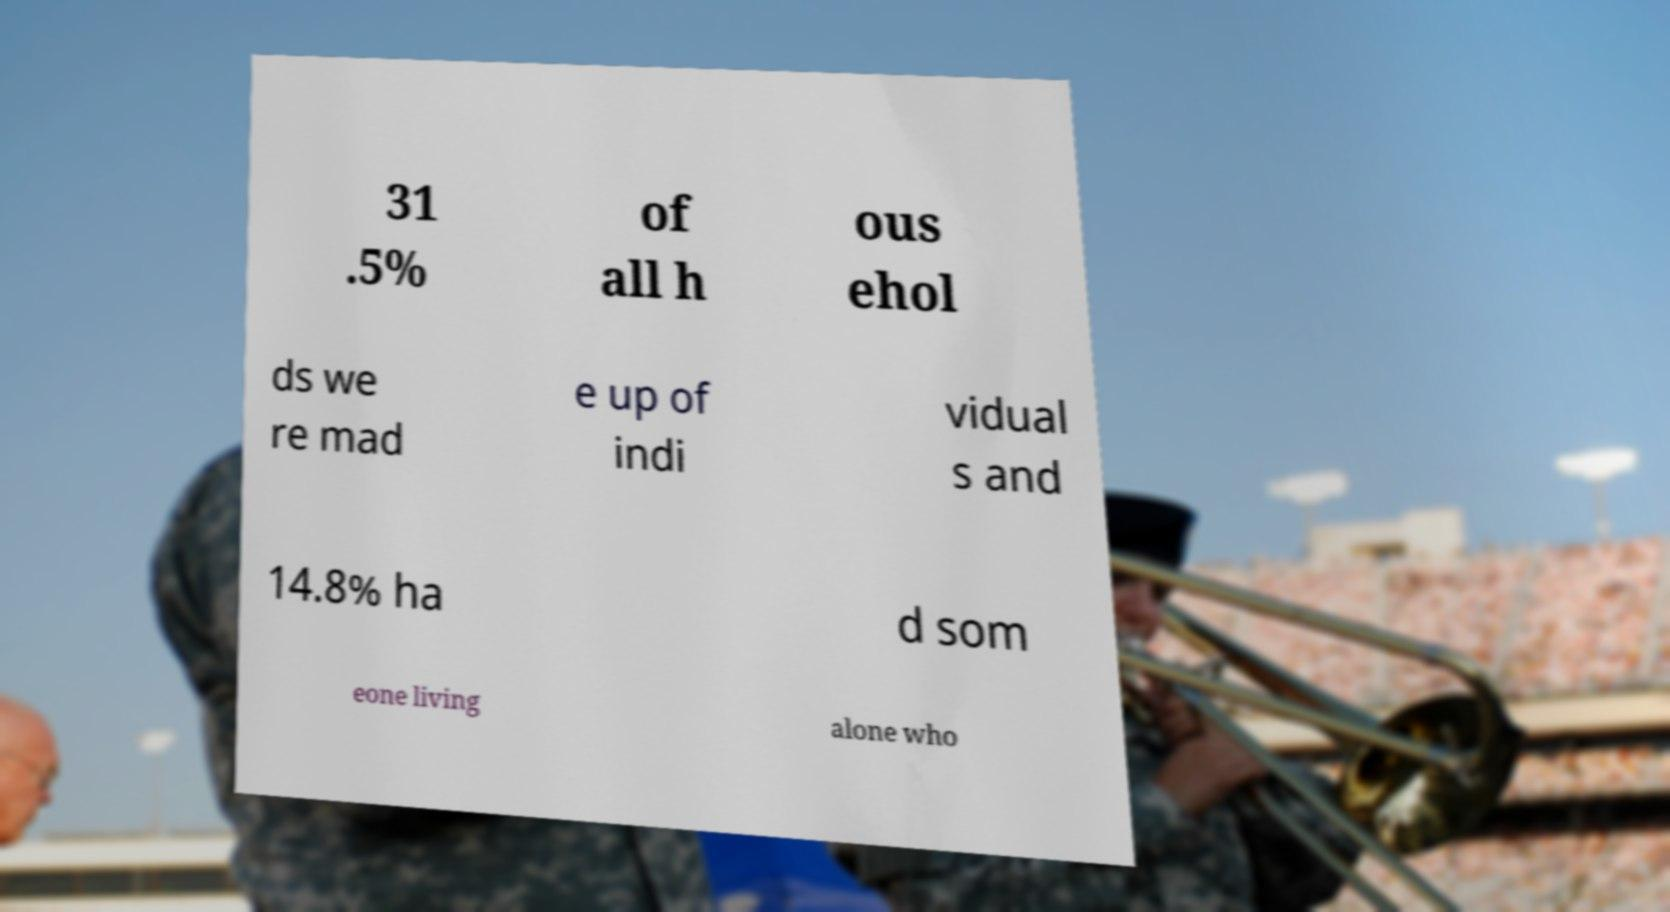Please identify and transcribe the text found in this image. 31 .5% of all h ous ehol ds we re mad e up of indi vidual s and 14.8% ha d som eone living alone who 